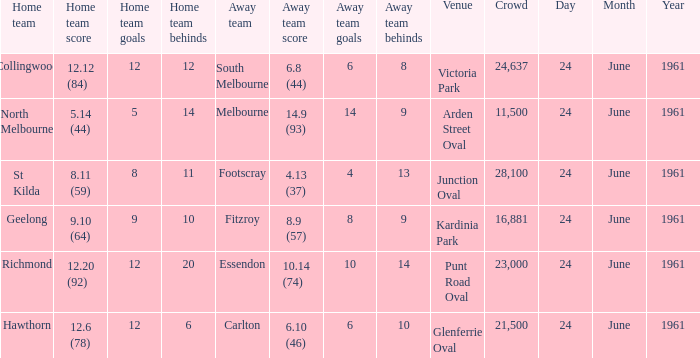What was the average crowd size of games held at Glenferrie Oval? 21500.0. 